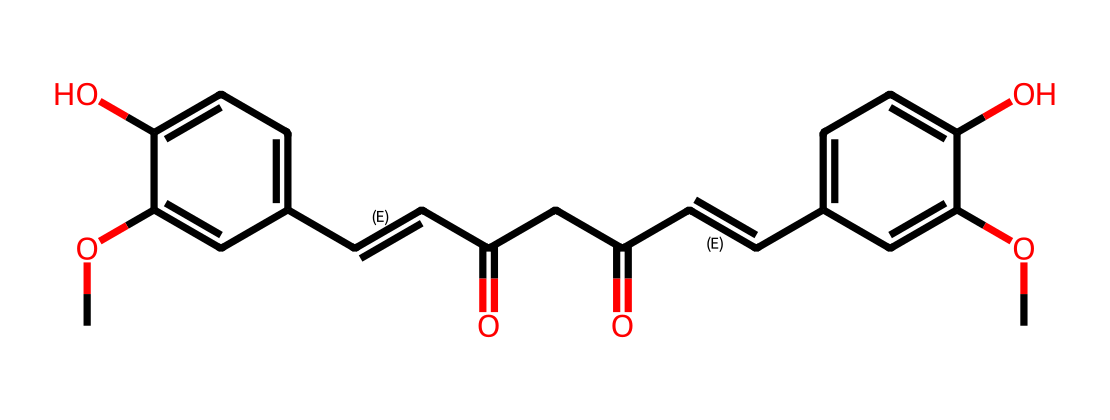What is the molecular formula of curcumin? By analyzing the structure represented by the SMILES notation, we can count the numbers of carbon, hydrogen, and oxygen atoms. The backbone of this molecule contains a specific carbon count along with oxygen atoms indicated among the functional groups. The total counts lead to the formulation of C21H20O6.
Answer: C21H20O6 How many oxygen atoms are present in curcumin? By examining the chemical structure represented in the SMILES, we can identify distinct –OH (hydroxyl) groups and carbonyl (C=O) groups that account for the oxygen atoms separately. When counted, there are a total of 6 oxygen atoms in the structure.
Answer: 6 What type of functional groups are present in curcumin? The structure features multiple functional groups, including hydroxyl (-OH) and carbonyl (C=O) groups. These groups are significant for the antioxidant properties of curcumin, indicating its reactivity and ability to scavenge free radicals.
Answer: hydroxyl and carbonyl Does curcumin contain double bonds? By inspecting the structure in the SMILES representation, one can see multiple locations that show the presence of double bonds (C=C). Double bonds are indicated explicitly in the representation, confirming their presence.
Answer: yes What role do the carbonyl groups play in the antioxidant activity of curcumin? Carbonyl groups in curcumin can serve as electron-withdrawing entities, stabilizing reactive intermediates formed during free radical scavenging. This chemical behavior enhances its antioxidant capacity, allowing it to effectively neutralize free radicals.
Answer: electron-withdrawing How many rings are in the curcumin structure? Analyzing the chemical's SMILES notation reveals a fused aromatic system indicating the presence of multiple ring structures. Upon careful observation, it can be determined that there are two aromatic rings in the structure.
Answer: 2 What is the primary reason curcumin is used in animal feed? Curcumin is primarily used in animal feed because of its antioxidant properties, which help in reducing oxidative stress and improving overall health in living organisms. The molecular structure contributes to its efficacy in this role.
Answer: antioxidant properties 